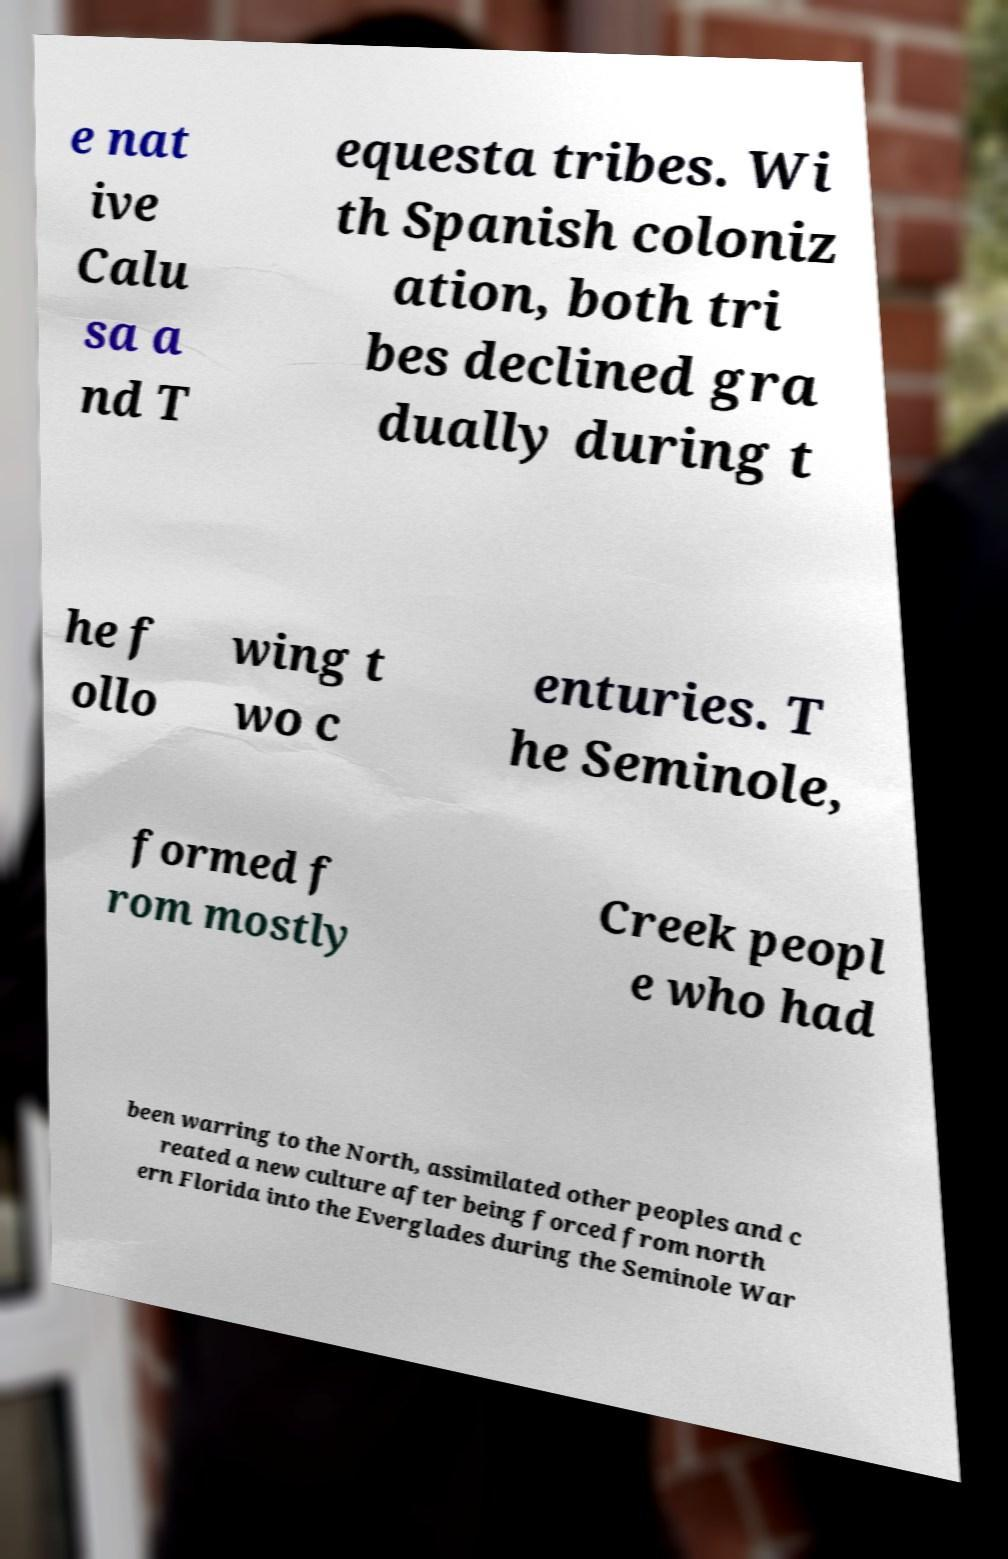Please identify and transcribe the text found in this image. e nat ive Calu sa a nd T equesta tribes. Wi th Spanish coloniz ation, both tri bes declined gra dually during t he f ollo wing t wo c enturies. T he Seminole, formed f rom mostly Creek peopl e who had been warring to the North, assimilated other peoples and c reated a new culture after being forced from north ern Florida into the Everglades during the Seminole War 